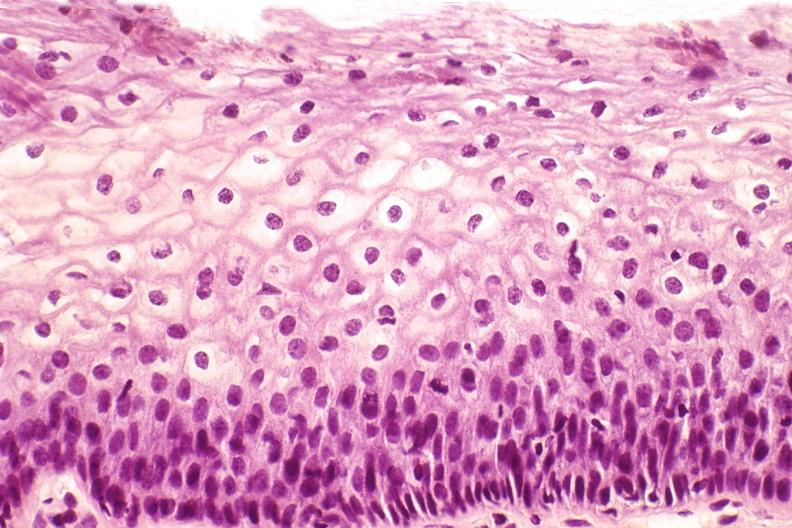s 70yof present?
Answer the question using a single word or phrase. No 